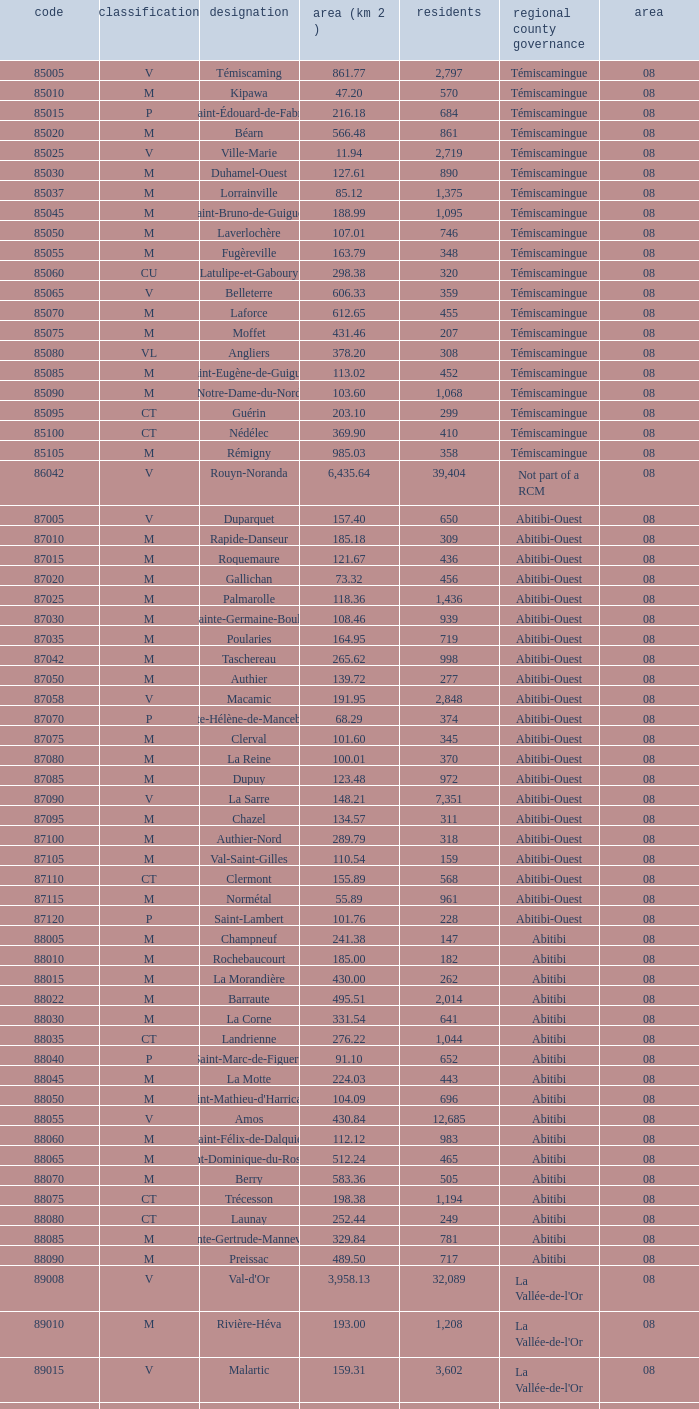What is Dupuy lowest area in km2? 123.48. 